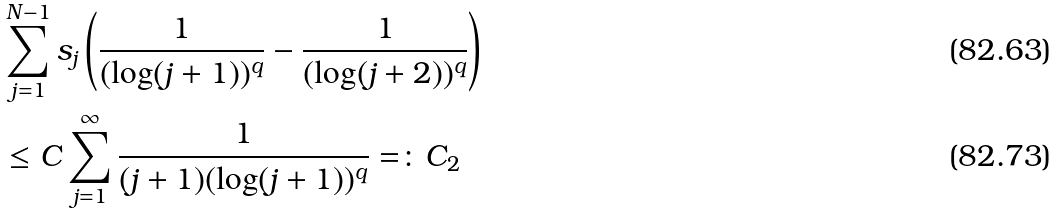<formula> <loc_0><loc_0><loc_500><loc_500>& \sum _ { j = 1 } ^ { N - 1 } s _ { j } \left ( \frac { 1 } { ( \log ( j + 1 ) ) ^ { q } } - \frac { 1 } { ( \log ( j + 2 ) ) ^ { q } } \right ) \\ & \leq C \sum _ { j = 1 } ^ { \infty } \frac { 1 } { ( j + 1 ) ( \log ( j + 1 ) ) ^ { q } } = \colon C _ { 2 }</formula> 